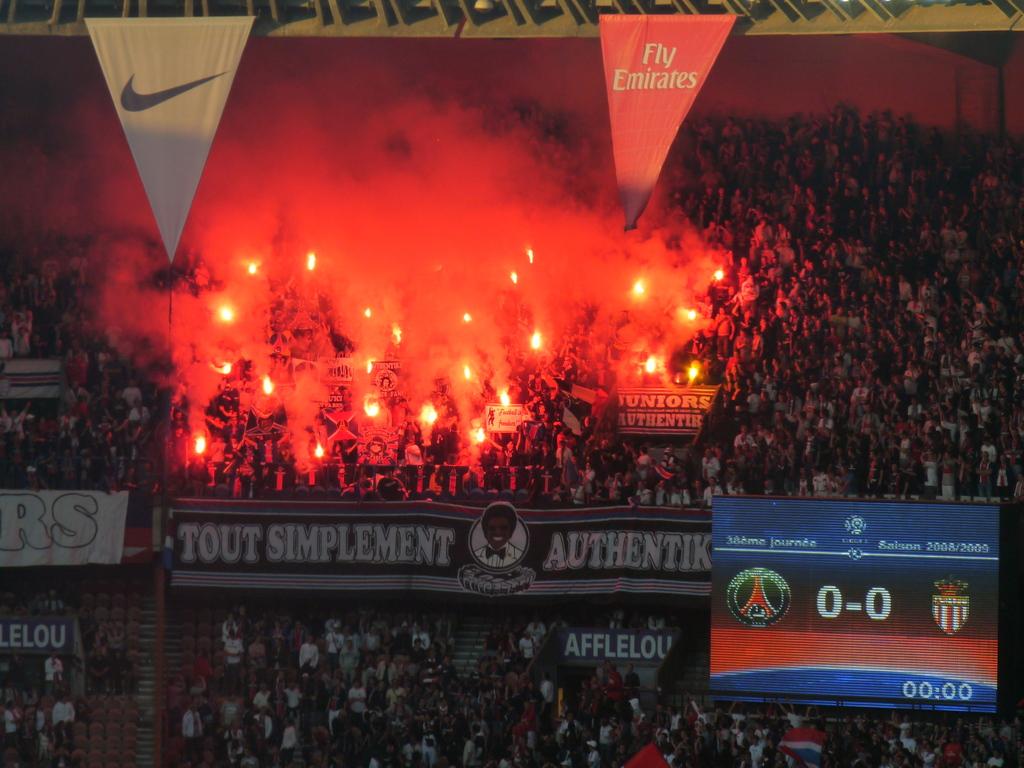What is the score of the game?
Your response must be concise. 0-0. 